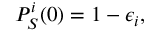<formula> <loc_0><loc_0><loc_500><loc_500>P _ { S } ^ { i } ( 0 ) = 1 - \epsilon _ { i } ,</formula> 